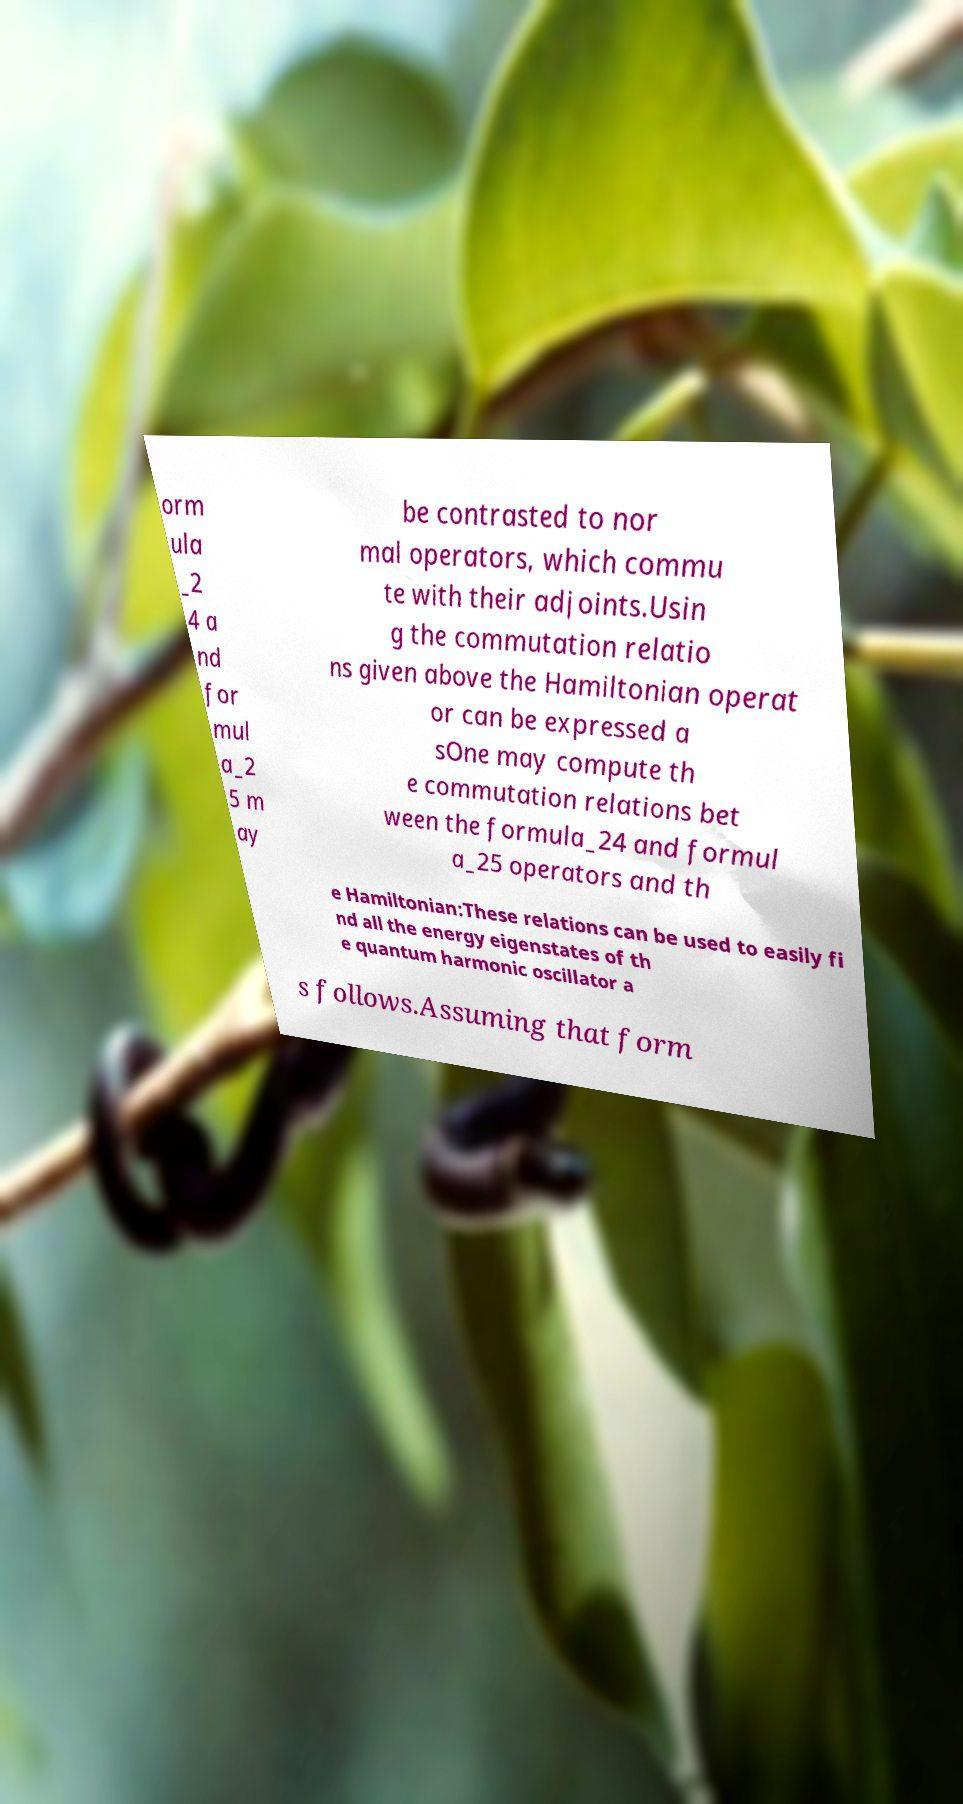I need the written content from this picture converted into text. Can you do that? orm ula _2 4 a nd for mul a_2 5 m ay be contrasted to nor mal operators, which commu te with their adjoints.Usin g the commutation relatio ns given above the Hamiltonian operat or can be expressed a sOne may compute th e commutation relations bet ween the formula_24 and formul a_25 operators and th e Hamiltonian:These relations can be used to easily fi nd all the energy eigenstates of th e quantum harmonic oscillator a s follows.Assuming that form 